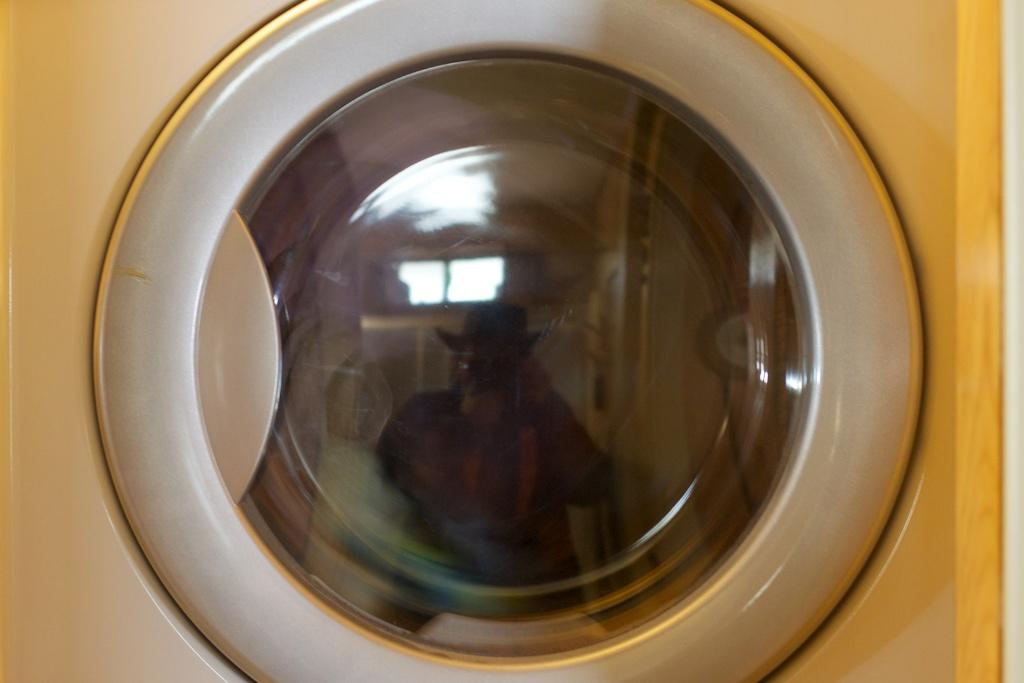What appliance can be seen in the image? There is a washing machine in the image. What feature does the washing machine have? The washing machine has a round glass. Where is the kitty sleeping in the image? There is no kitty present in the image. What type of tent is set up in the background of the image? There is no tent present in the image. 